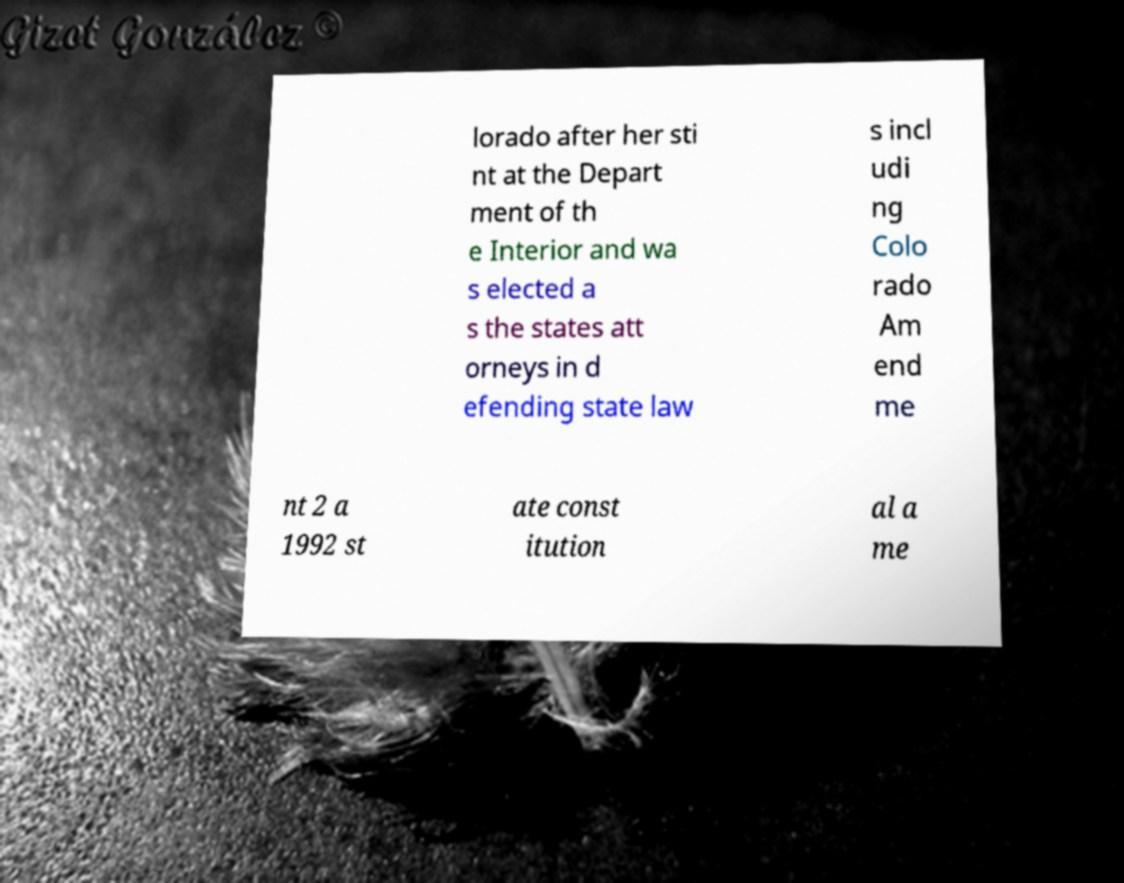There's text embedded in this image that I need extracted. Can you transcribe it verbatim? lorado after her sti nt at the Depart ment of th e Interior and wa s elected a s the states att orneys in d efending state law s incl udi ng Colo rado Am end me nt 2 a 1992 st ate const itution al a me 